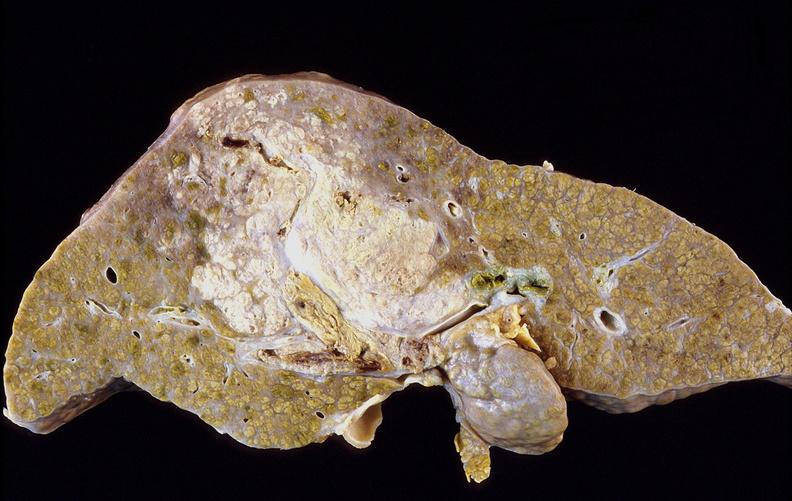s this myoma present?
Answer the question using a single word or phrase. No 